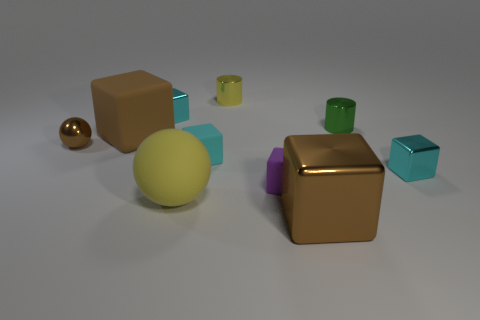Subtract all large cubes. How many cubes are left? 4 Subtract all blue balls. How many cyan blocks are left? 3 Subtract all brown cubes. How many cubes are left? 4 Subtract 1 blocks. How many blocks are left? 5 Subtract all spheres. How many objects are left? 8 Subtract all yellow cubes. Subtract all red spheres. How many cubes are left? 6 Add 5 small yellow metallic things. How many small yellow metallic things exist? 6 Subtract 0 blue cylinders. How many objects are left? 10 Subtract all large brown blocks. Subtract all small green shiny balls. How many objects are left? 8 Add 4 big brown cubes. How many big brown cubes are left? 6 